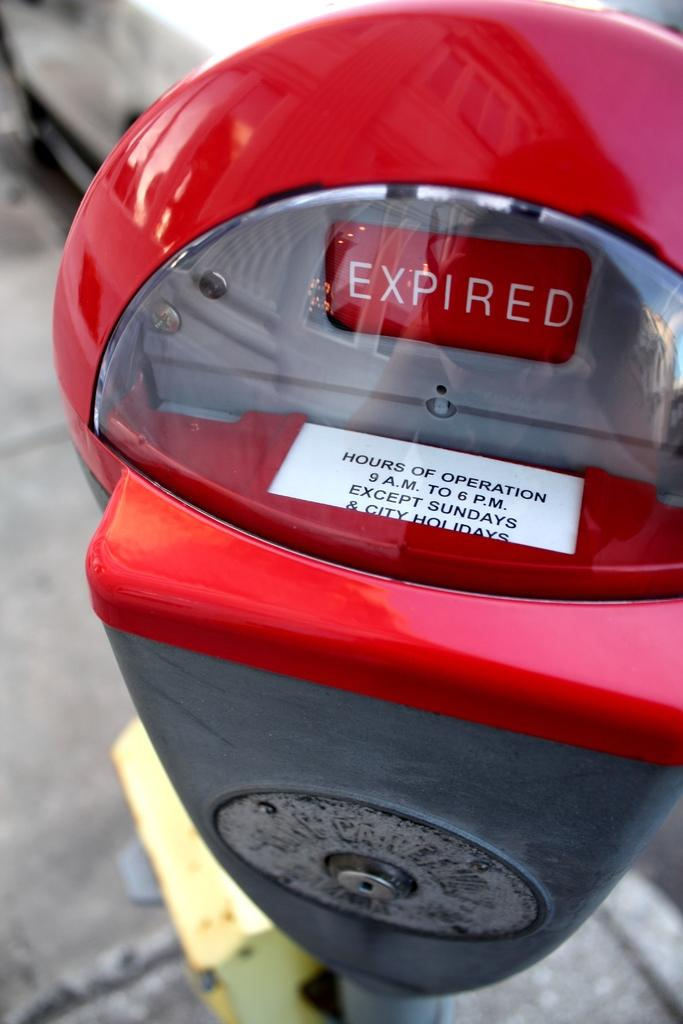<image>
Describe the image concisely. A red parking meter with a car in the background reads Expired. 